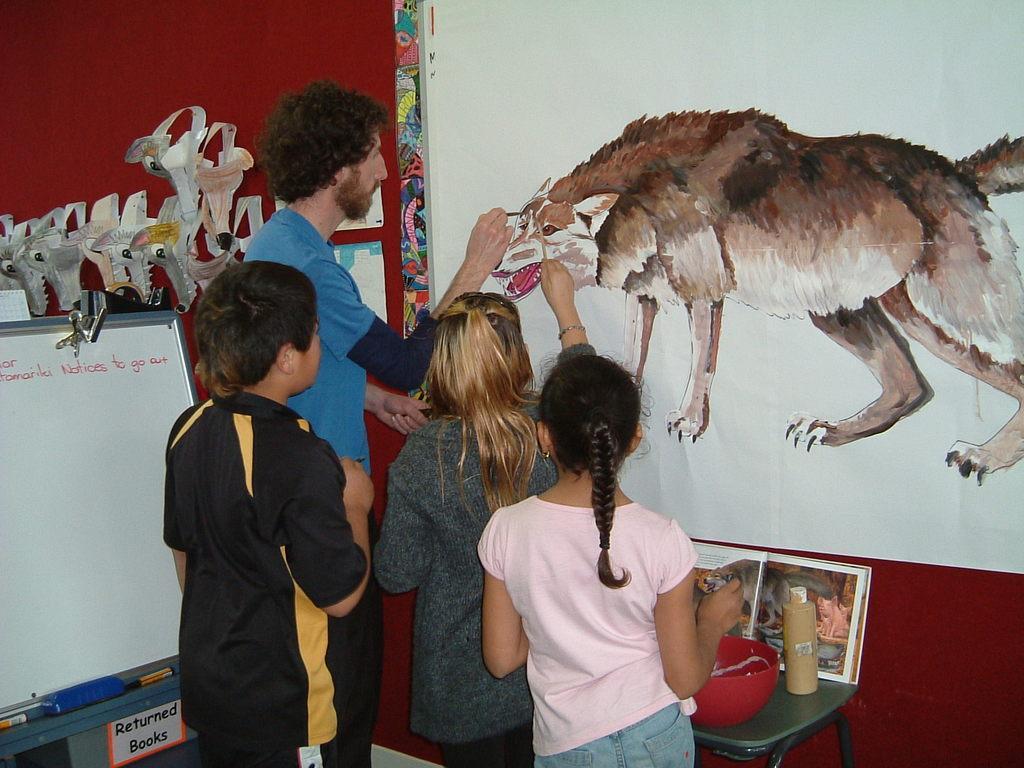Can you describe this image briefly? In this picture we can see people holding brushes and painting on the wall. On a table we can see a bottle, bowl and a book. On the left side of the picture we can see few objects, whiteboard, markers, text and duster. 